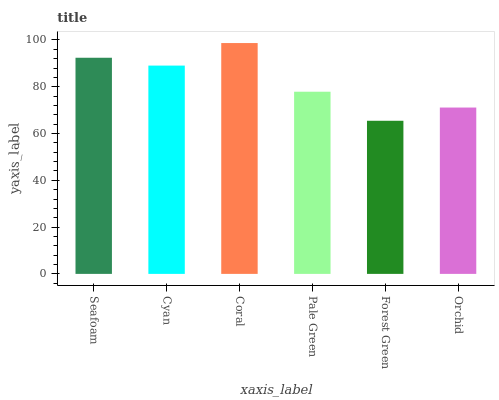Is Forest Green the minimum?
Answer yes or no. Yes. Is Coral the maximum?
Answer yes or no. Yes. Is Cyan the minimum?
Answer yes or no. No. Is Cyan the maximum?
Answer yes or no. No. Is Seafoam greater than Cyan?
Answer yes or no. Yes. Is Cyan less than Seafoam?
Answer yes or no. Yes. Is Cyan greater than Seafoam?
Answer yes or no. No. Is Seafoam less than Cyan?
Answer yes or no. No. Is Cyan the high median?
Answer yes or no. Yes. Is Pale Green the low median?
Answer yes or no. Yes. Is Forest Green the high median?
Answer yes or no. No. Is Coral the low median?
Answer yes or no. No. 